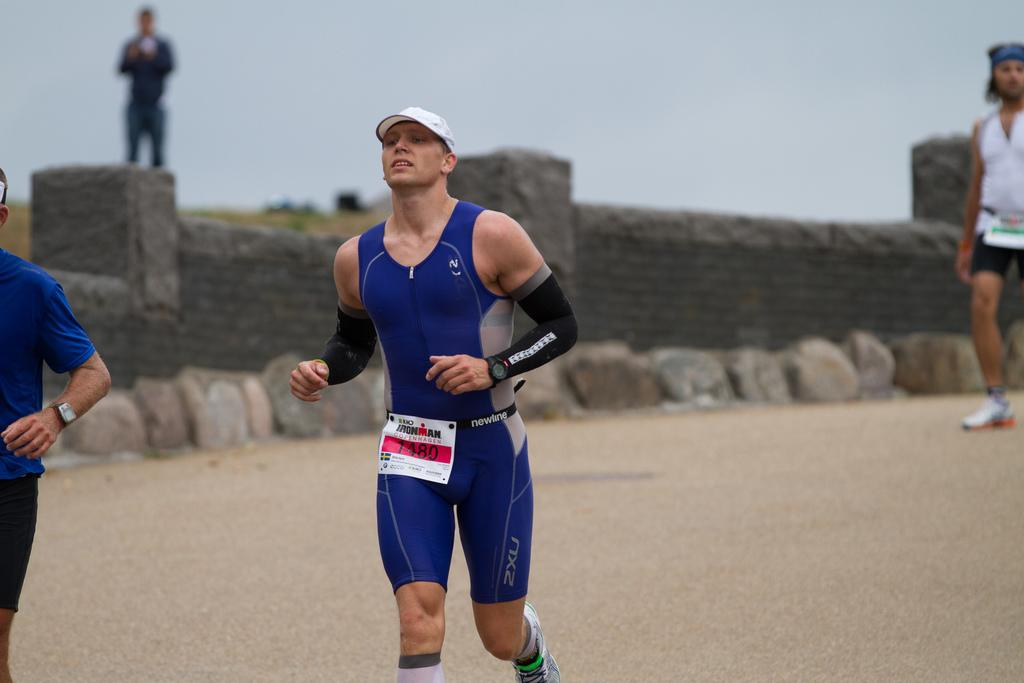What are the people in the image doing? The people in the image are jogging on the road. Can you describe the person who is not jogging? There is a person standing on a wall. What can be seen in the background of the image? The sky is visible in the image. What position does the committee hold in the image? There is no committee present in the image. How many planes can be seen flying in the image? There are no planes visible in the image. 